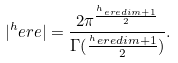<formula> <loc_0><loc_0><loc_500><loc_500>| ^ { h } e r e | = \frac { 2 \pi ^ { \frac { ^ { h } e r e d i m + 1 } { 2 } } } { \Gamma ( \frac { ^ { h } e r e d i m + 1 } { 2 } ) } .</formula> 